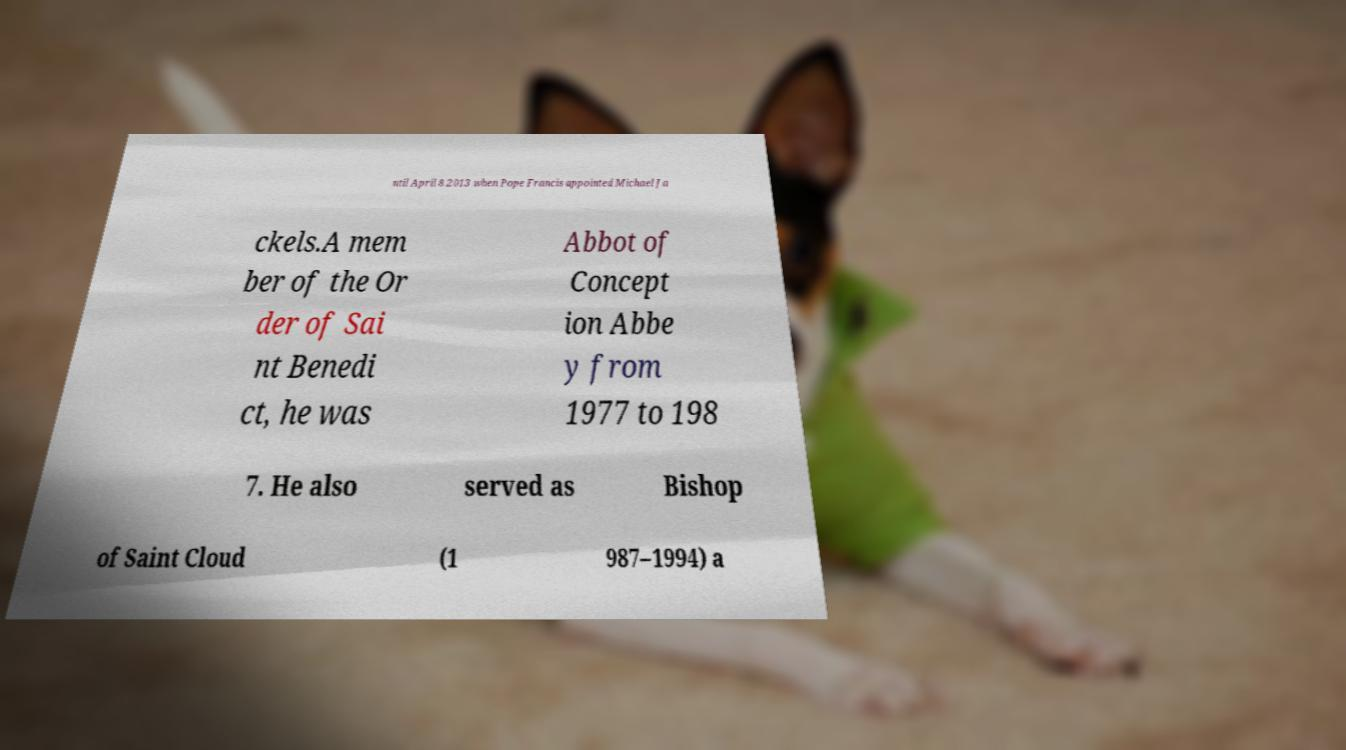I need the written content from this picture converted into text. Can you do that? ntil April 8 2013 when Pope Francis appointed Michael Ja ckels.A mem ber of the Or der of Sai nt Benedi ct, he was Abbot of Concept ion Abbe y from 1977 to 198 7. He also served as Bishop of Saint Cloud (1 987–1994) a 